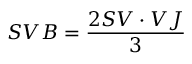Convert formula to latex. <formula><loc_0><loc_0><loc_500><loc_500>S V B = { \frac { 2 S V \cdot V J } { 3 } }</formula> 